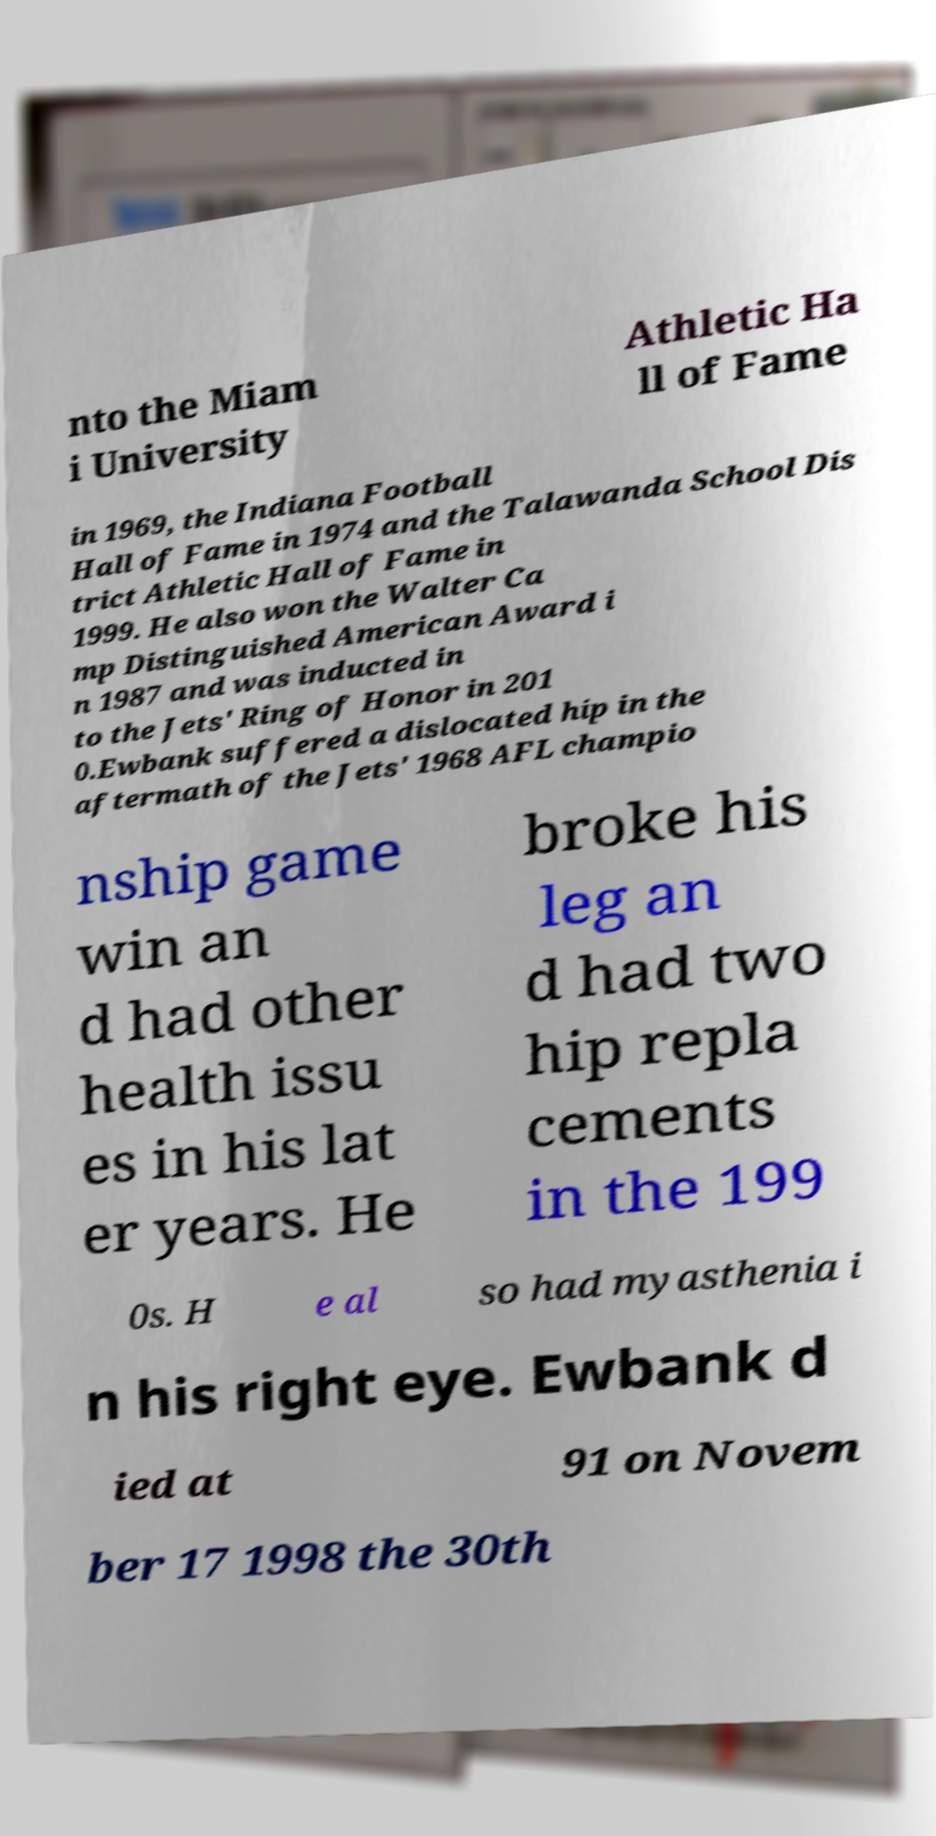I need the written content from this picture converted into text. Can you do that? nto the Miam i University Athletic Ha ll of Fame in 1969, the Indiana Football Hall of Fame in 1974 and the Talawanda School Dis trict Athletic Hall of Fame in 1999. He also won the Walter Ca mp Distinguished American Award i n 1987 and was inducted in to the Jets' Ring of Honor in 201 0.Ewbank suffered a dislocated hip in the aftermath of the Jets' 1968 AFL champio nship game win an d had other health issu es in his lat er years. He broke his leg an d had two hip repla cements in the 199 0s. H e al so had myasthenia i n his right eye. Ewbank d ied at 91 on Novem ber 17 1998 the 30th 